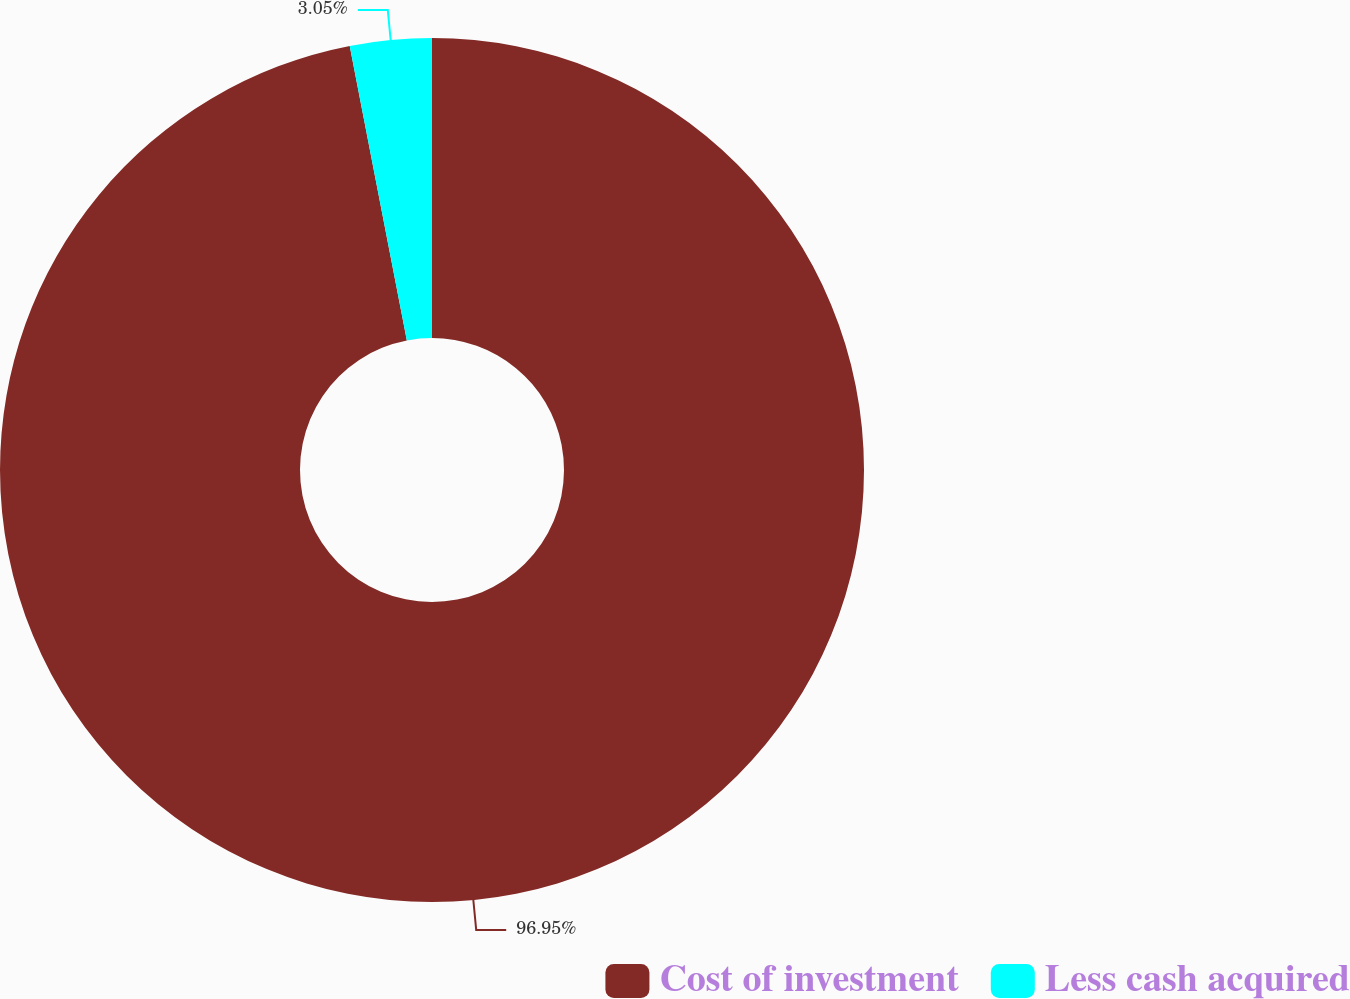<chart> <loc_0><loc_0><loc_500><loc_500><pie_chart><fcel>Cost of investment<fcel>Less cash acquired<nl><fcel>96.95%<fcel>3.05%<nl></chart> 